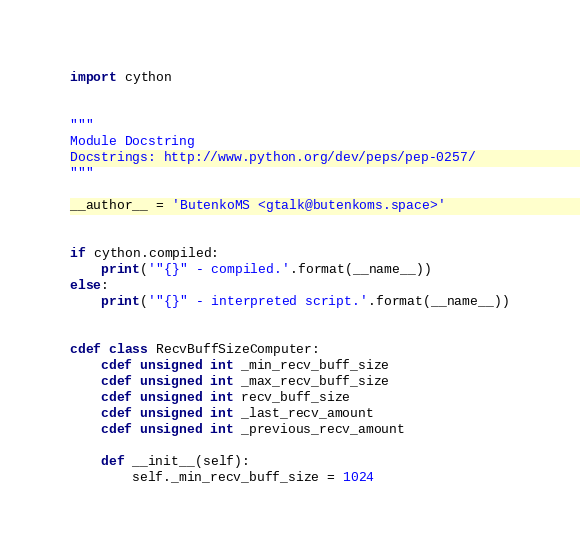<code> <loc_0><loc_0><loc_500><loc_500><_Cython_>import cython


"""
Module Docstring
Docstrings: http://www.python.org/dev/peps/pep-0257/
"""

__author__ = 'ButenkoMS <gtalk@butenkoms.space>'


if cython.compiled:
    print('"{}" - compiled.'.format(__name__))
else:
    print('"{}" - interpreted script.'.format(__name__))


cdef class RecvBuffSizeComputer:
    cdef unsigned int _min_recv_buff_size
    cdef unsigned int _max_recv_buff_size
    cdef unsigned int recv_buff_size
    cdef unsigned int _last_recv_amount
    cdef unsigned int _previous_recv_amount

    def __init__(self):
        self._min_recv_buff_size = 1024</code> 